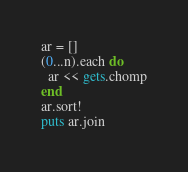Convert code to text. <code><loc_0><loc_0><loc_500><loc_500><_Ruby_>ar = []
(0...n).each do
  ar << gets.chomp
end
ar.sort!
puts ar.join</code> 